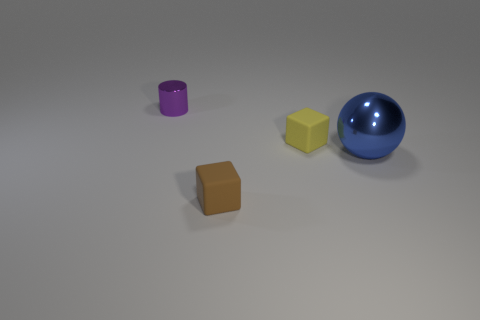Does the rubber block that is behind the brown rubber object have the same size as the large blue ball?
Give a very brief answer. No. What shape is the thing that is both left of the large blue metal sphere and in front of the yellow matte object?
Give a very brief answer. Cube. Is the number of cubes left of the yellow thing greater than the number of small red blocks?
Keep it short and to the point. Yes. What is the size of the object that is the same material as the yellow cube?
Offer a terse response. Small. Is the number of tiny yellow blocks that are to the left of the small metal object the same as the number of small things in front of the big blue shiny thing?
Your response must be concise. No. There is a rubber cube in front of the yellow block; what is its color?
Offer a terse response. Brown. Are there an equal number of blue metal objects that are to the right of the large blue metallic ball and purple objects?
Make the answer very short. No. How many other things are the same shape as the big blue thing?
Provide a short and direct response. 0. There is a purple metal cylinder; what number of brown blocks are to the right of it?
Keep it short and to the point. 1. What is the size of the object that is both in front of the small yellow matte object and behind the small brown matte object?
Offer a very short reply. Large. 